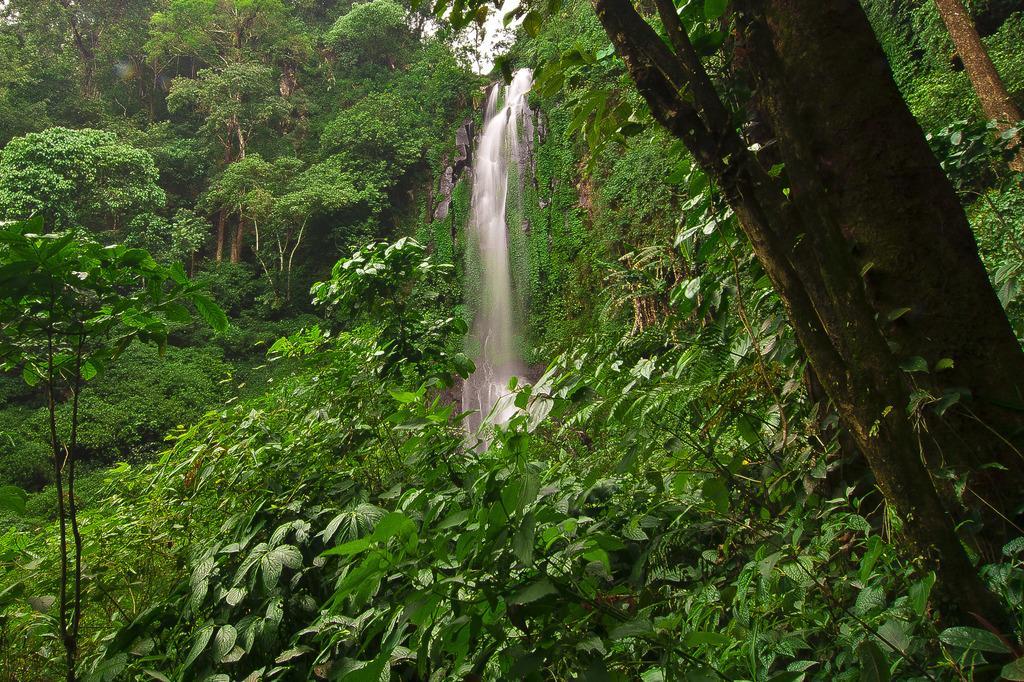Could you give a brief overview of what you see in this image? This picture might be taken in a forest in this picture, in the center there is one water fall and in the foreground and background there are some trees. 